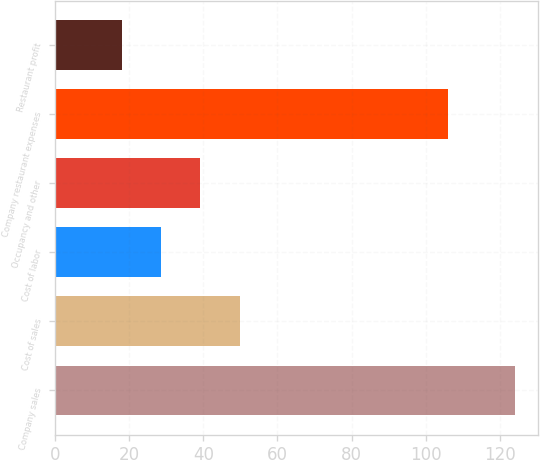Convert chart to OTSL. <chart><loc_0><loc_0><loc_500><loc_500><bar_chart><fcel>Company sales<fcel>Cost of sales<fcel>Cost of labor<fcel>Occupancy and other<fcel>Company restaurant expenses<fcel>Restaurant profit<nl><fcel>124<fcel>49.8<fcel>28.6<fcel>39.2<fcel>106<fcel>18<nl></chart> 